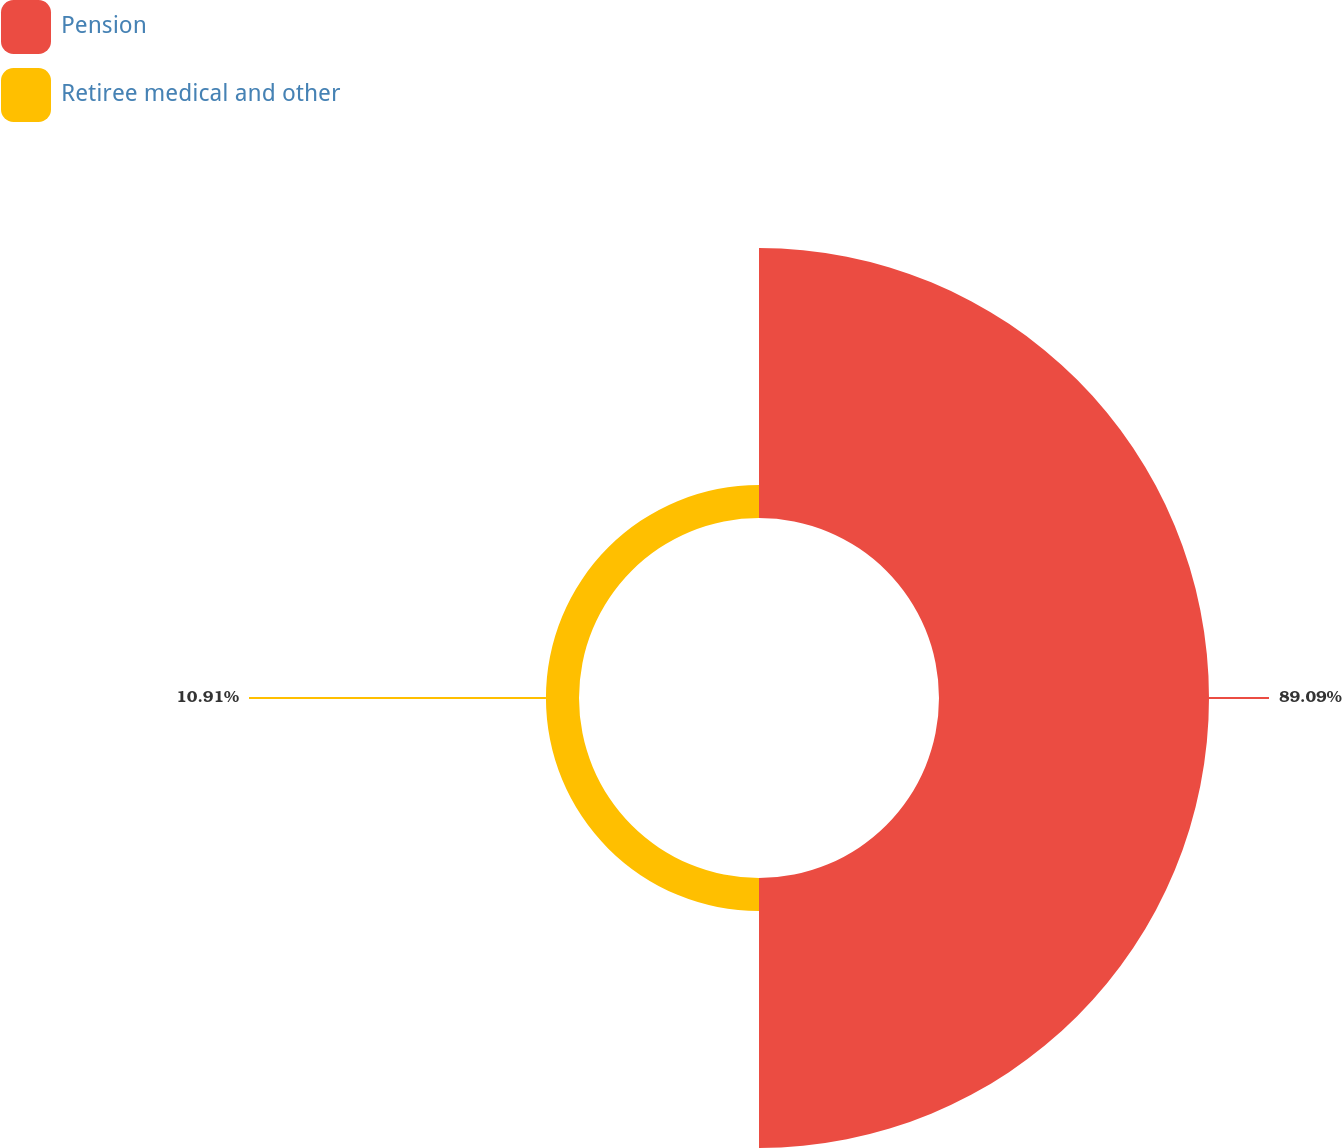<chart> <loc_0><loc_0><loc_500><loc_500><pie_chart><fcel>Pension<fcel>Retiree medical and other<nl><fcel>89.09%<fcel>10.91%<nl></chart> 